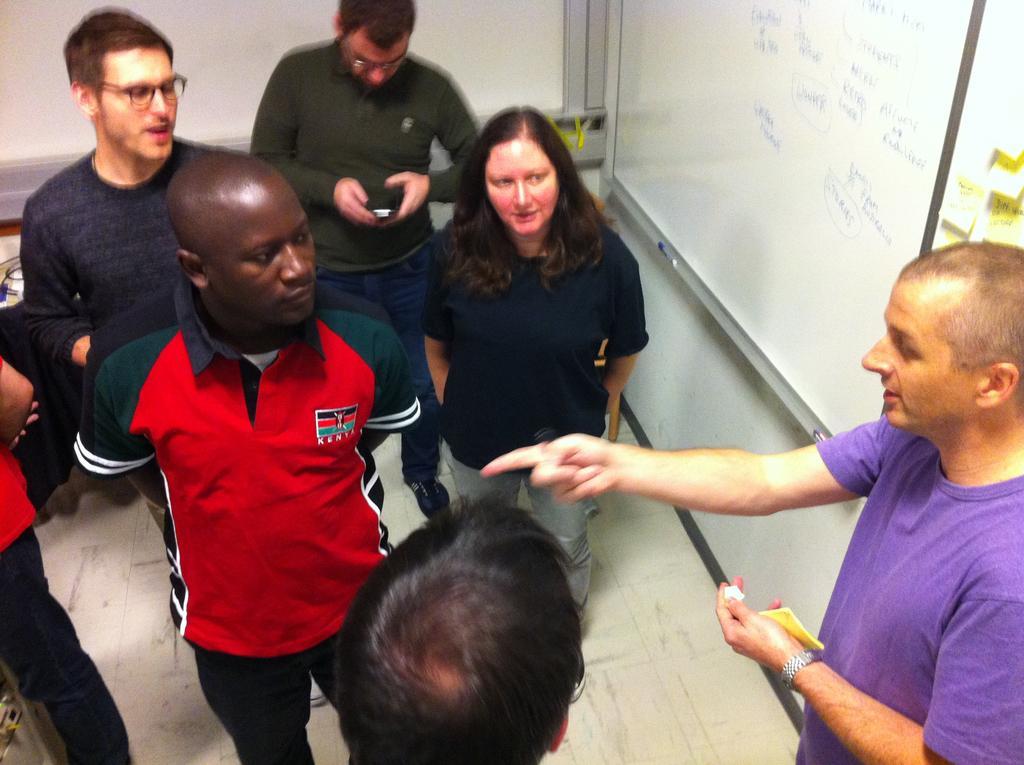Could you give a brief overview of what you see in this image? As we can see in the image there is a board and group of people standing over here. The person over here is holding a mobile phone. 